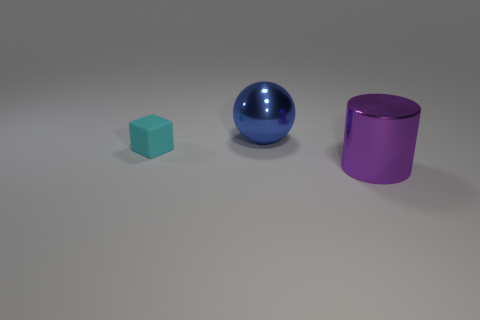Add 2 large brown things. How many objects exist? 5 Subtract all spheres. How many objects are left? 2 Subtract 1 blue balls. How many objects are left? 2 Subtract all big purple shiny objects. Subtract all large purple cylinders. How many objects are left? 1 Add 1 cyan blocks. How many cyan blocks are left? 2 Add 3 cyan matte blocks. How many cyan matte blocks exist? 4 